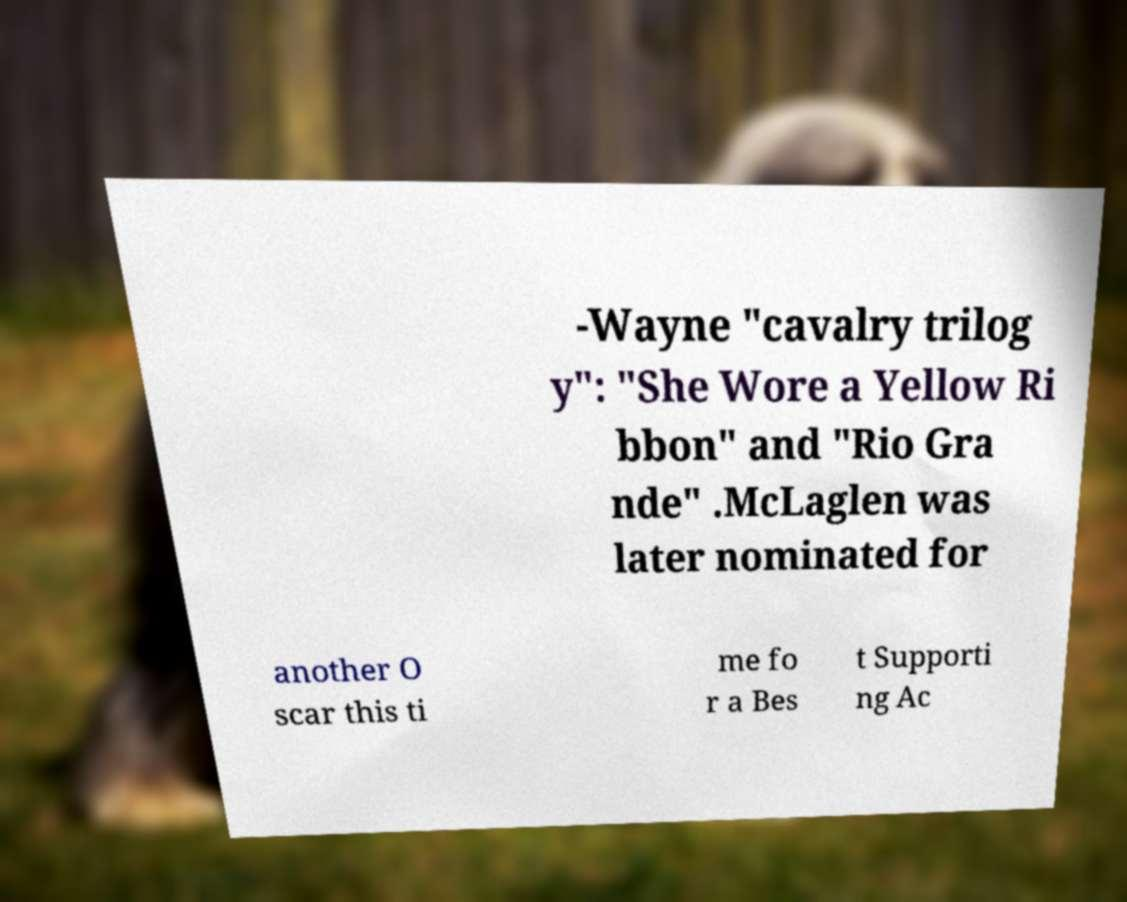Please identify and transcribe the text found in this image. -Wayne "cavalry trilog y": "She Wore a Yellow Ri bbon" and "Rio Gra nde" .McLaglen was later nominated for another O scar this ti me fo r a Bes t Supporti ng Ac 